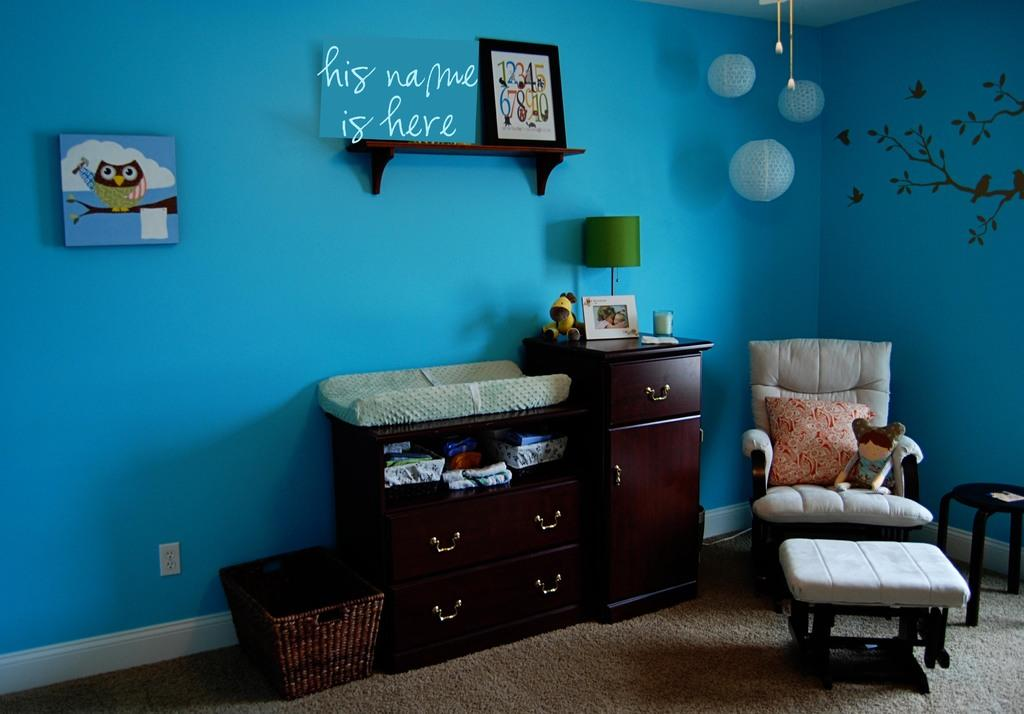Provide a one-sentence caption for the provided image. A blue nursery with a "his name is here" sign above the changing table. 